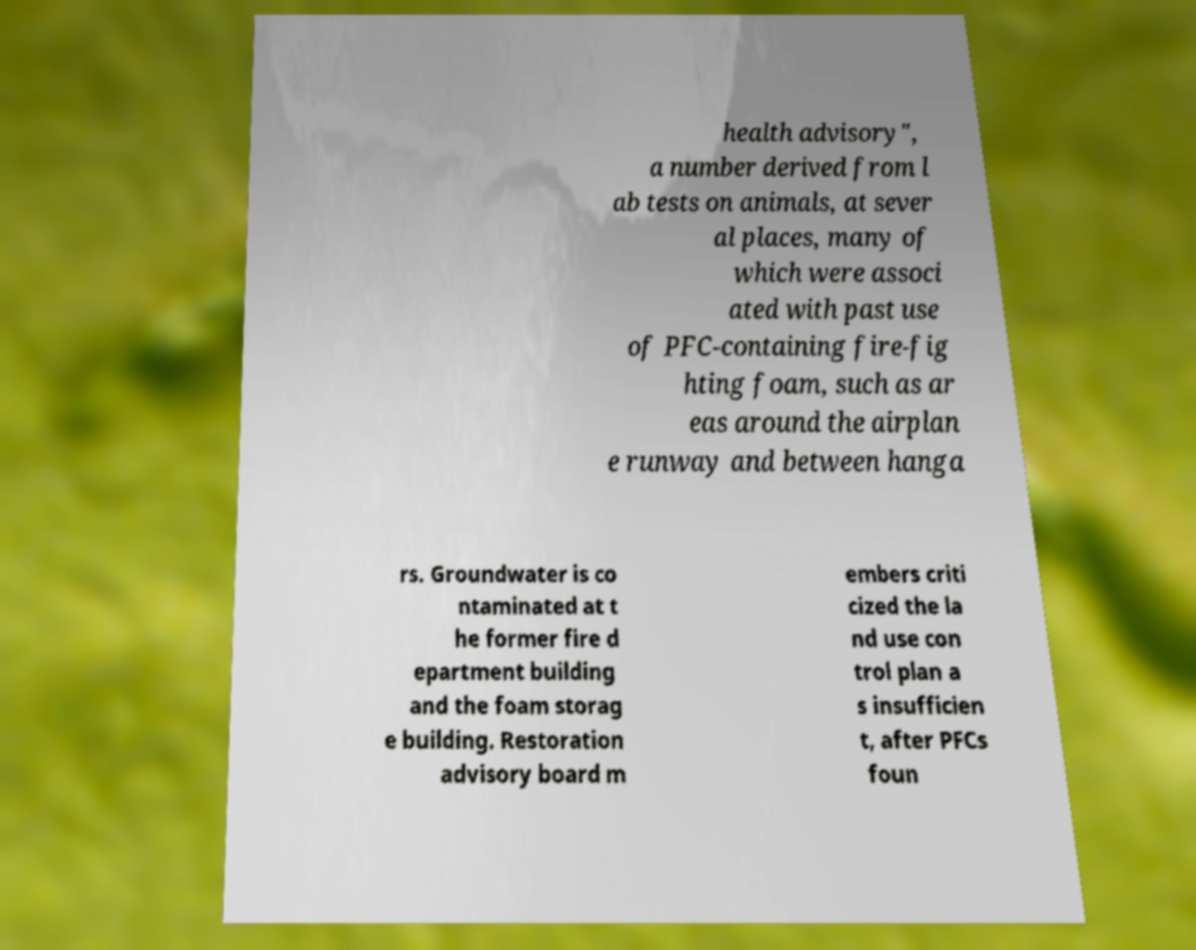Can you read and provide the text displayed in the image?This photo seems to have some interesting text. Can you extract and type it out for me? health advisory", a number derived from l ab tests on animals, at sever al places, many of which were associ ated with past use of PFC-containing fire-fig hting foam, such as ar eas around the airplan e runway and between hanga rs. Groundwater is co ntaminated at t he former fire d epartment building and the foam storag e building. Restoration advisory board m embers criti cized the la nd use con trol plan a s insufficien t, after PFCs foun 